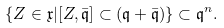<formula> <loc_0><loc_0><loc_500><loc_500>\{ Z \in \mathfrak { x } | [ Z , \bar { \mathfrak { q } } ] \subset ( \mathfrak { q } + \bar { \mathfrak { q } } ) \} \subset \mathfrak { q } ^ { n } .</formula> 